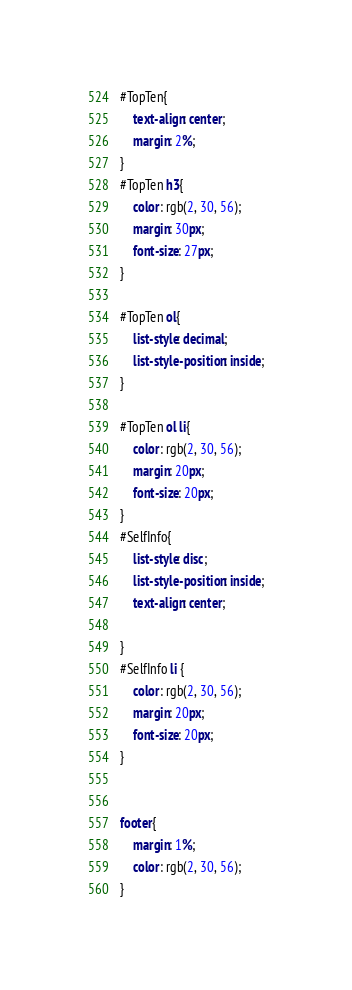Convert code to text. <code><loc_0><loc_0><loc_500><loc_500><_CSS_>
#TopTen{
    text-align: center;
    margin: 2%;
}
#TopTen h3{
    color: rgb(2, 30, 56);
    margin: 30px;
    font-size: 27px;
}

#TopTen ol{
    list-style: decimal;
    list-style-position: inside;
}

#TopTen ol li{
    color: rgb(2, 30, 56);
    margin: 20px;
    font-size: 20px;
}
#SelfInfo{
    list-style: disc;
    list-style-position: inside;
    text-align: center;

}
#SelfInfo li {
    color: rgb(2, 30, 56);
    margin: 20px;
    font-size: 20px;
}


footer{
    margin: 1%;
    color: rgb(2, 30, 56);
}</code> 